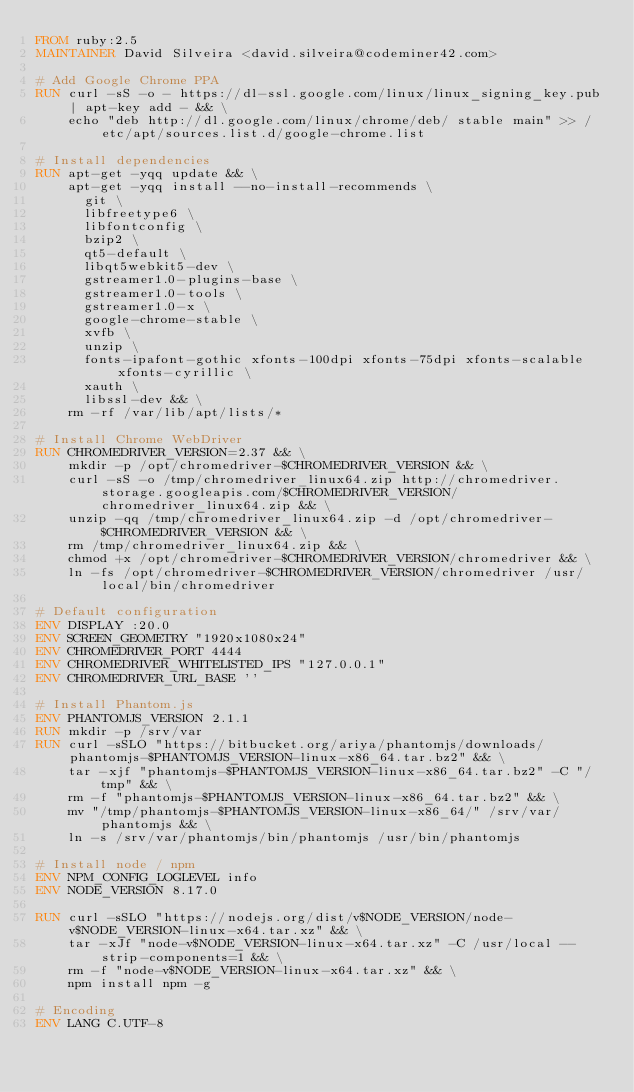<code> <loc_0><loc_0><loc_500><loc_500><_Dockerfile_>FROM ruby:2.5
MAINTAINER David Silveira <david.silveira@codeminer42.com>

# Add Google Chrome PPA
RUN curl -sS -o - https://dl-ssl.google.com/linux/linux_signing_key.pub | apt-key add - && \
    echo "deb http://dl.google.com/linux/chrome/deb/ stable main" >> /etc/apt/sources.list.d/google-chrome.list

# Install dependencies
RUN apt-get -yqq update && \
    apt-get -yqq install --no-install-recommends \
      git \
      libfreetype6 \
      libfontconfig \
      bzip2 \
      qt5-default \
      libqt5webkit5-dev \
      gstreamer1.0-plugins-base \
      gstreamer1.0-tools \
      gstreamer1.0-x \
      google-chrome-stable \
      xvfb \
      unzip \
      fonts-ipafont-gothic xfonts-100dpi xfonts-75dpi xfonts-scalable xfonts-cyrillic \
      xauth \
      libssl-dev && \
    rm -rf /var/lib/apt/lists/*

# Install Chrome WebDriver
RUN CHROMEDRIVER_VERSION=2.37 && \
    mkdir -p /opt/chromedriver-$CHROMEDRIVER_VERSION && \
    curl -sS -o /tmp/chromedriver_linux64.zip http://chromedriver.storage.googleapis.com/$CHROMEDRIVER_VERSION/chromedriver_linux64.zip && \
    unzip -qq /tmp/chromedriver_linux64.zip -d /opt/chromedriver-$CHROMEDRIVER_VERSION && \
    rm /tmp/chromedriver_linux64.zip && \
    chmod +x /opt/chromedriver-$CHROMEDRIVER_VERSION/chromedriver && \
    ln -fs /opt/chromedriver-$CHROMEDRIVER_VERSION/chromedriver /usr/local/bin/chromedriver

# Default configuration
ENV DISPLAY :20.0
ENV SCREEN_GEOMETRY "1920x1080x24"
ENV CHROMEDRIVER_PORT 4444
ENV CHROMEDRIVER_WHITELISTED_IPS "127.0.0.1"
ENV CHROMEDRIVER_URL_BASE ''

# Install Phantom.js
ENV PHANTOMJS_VERSION 2.1.1
RUN mkdir -p /srv/var
RUN curl -sSLO "https://bitbucket.org/ariya/phantomjs/downloads/phantomjs-$PHANTOMJS_VERSION-linux-x86_64.tar.bz2" && \
    tar -xjf "phantomjs-$PHANTOMJS_VERSION-linux-x86_64.tar.bz2" -C "/tmp" && \
    rm -f "phantomjs-$PHANTOMJS_VERSION-linux-x86_64.tar.bz2" && \
    mv "/tmp/phantomjs-$PHANTOMJS_VERSION-linux-x86_64/" /srv/var/phantomjs && \
    ln -s /srv/var/phantomjs/bin/phantomjs /usr/bin/phantomjs

# Install node / npm
ENV NPM_CONFIG_LOGLEVEL info
ENV NODE_VERSION 8.17.0

RUN curl -sSLO "https://nodejs.org/dist/v$NODE_VERSION/node-v$NODE_VERSION-linux-x64.tar.xz" && \
    tar -xJf "node-v$NODE_VERSION-linux-x64.tar.xz" -C /usr/local --strip-components=1 && \
    rm -f "node-v$NODE_VERSION-linux-x64.tar.xz" && \
    npm install npm -g

# Encoding
ENV LANG C.UTF-8
</code> 